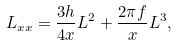<formula> <loc_0><loc_0><loc_500><loc_500>L _ { x x } = \frac { 3 h } { 4 x } L ^ { 2 } + \frac { 2 \pi f } x L ^ { 3 } ,</formula> 